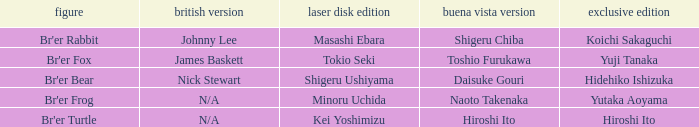Who is the character where the special edition is koichi sakaguchi? Br'er Rabbit. 